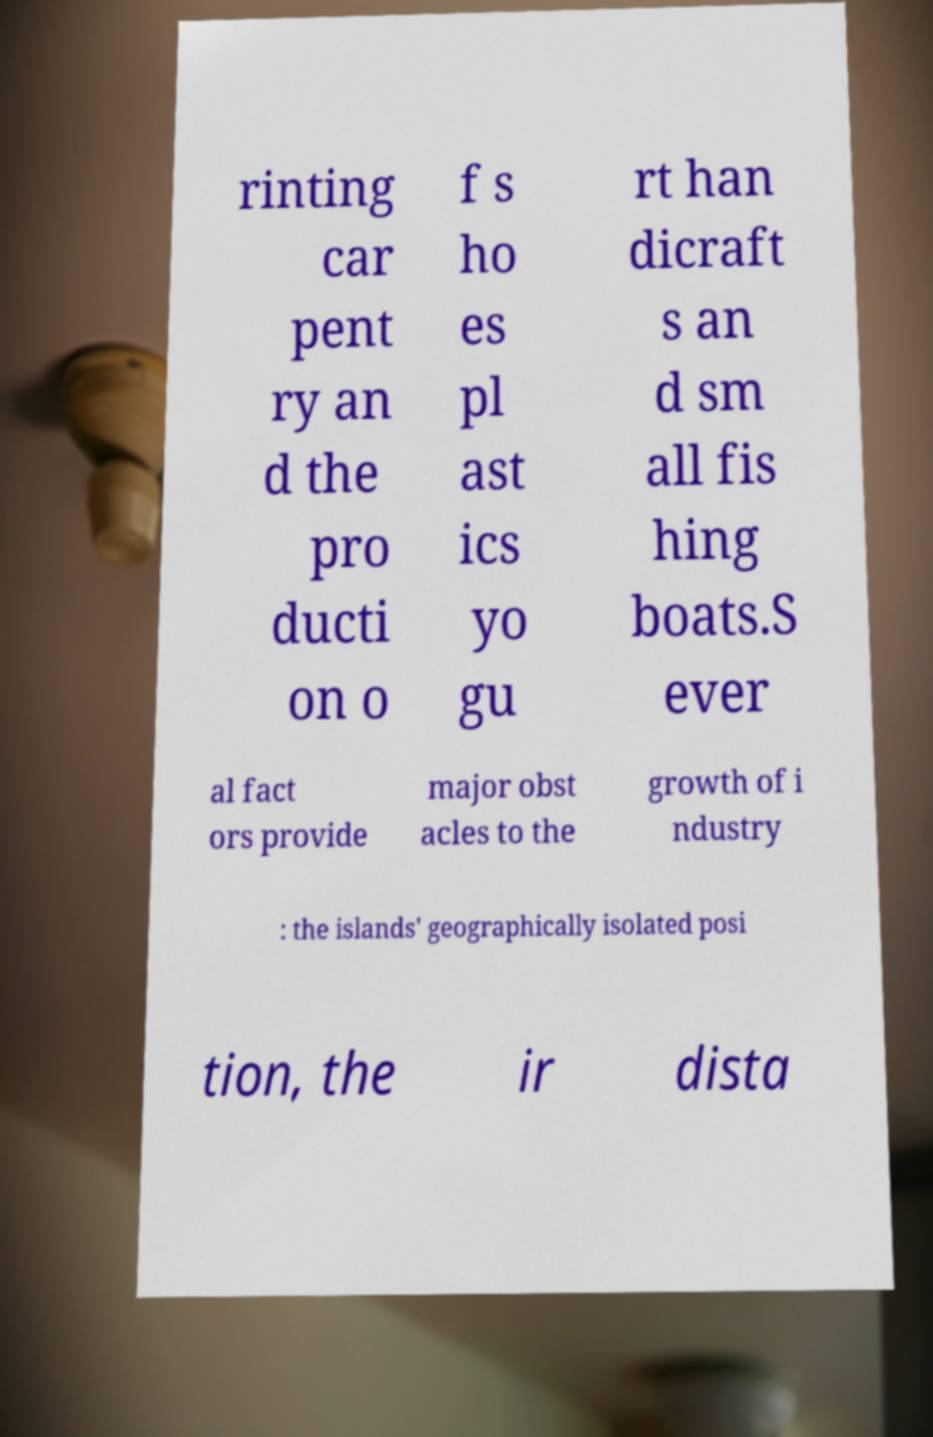Please read and relay the text visible in this image. What does it say? rinting car pent ry an d the pro ducti on o f s ho es pl ast ics yo gu rt han dicraft s an d sm all fis hing boats.S ever al fact ors provide major obst acles to the growth of i ndustry : the islands' geographically isolated posi tion, the ir dista 